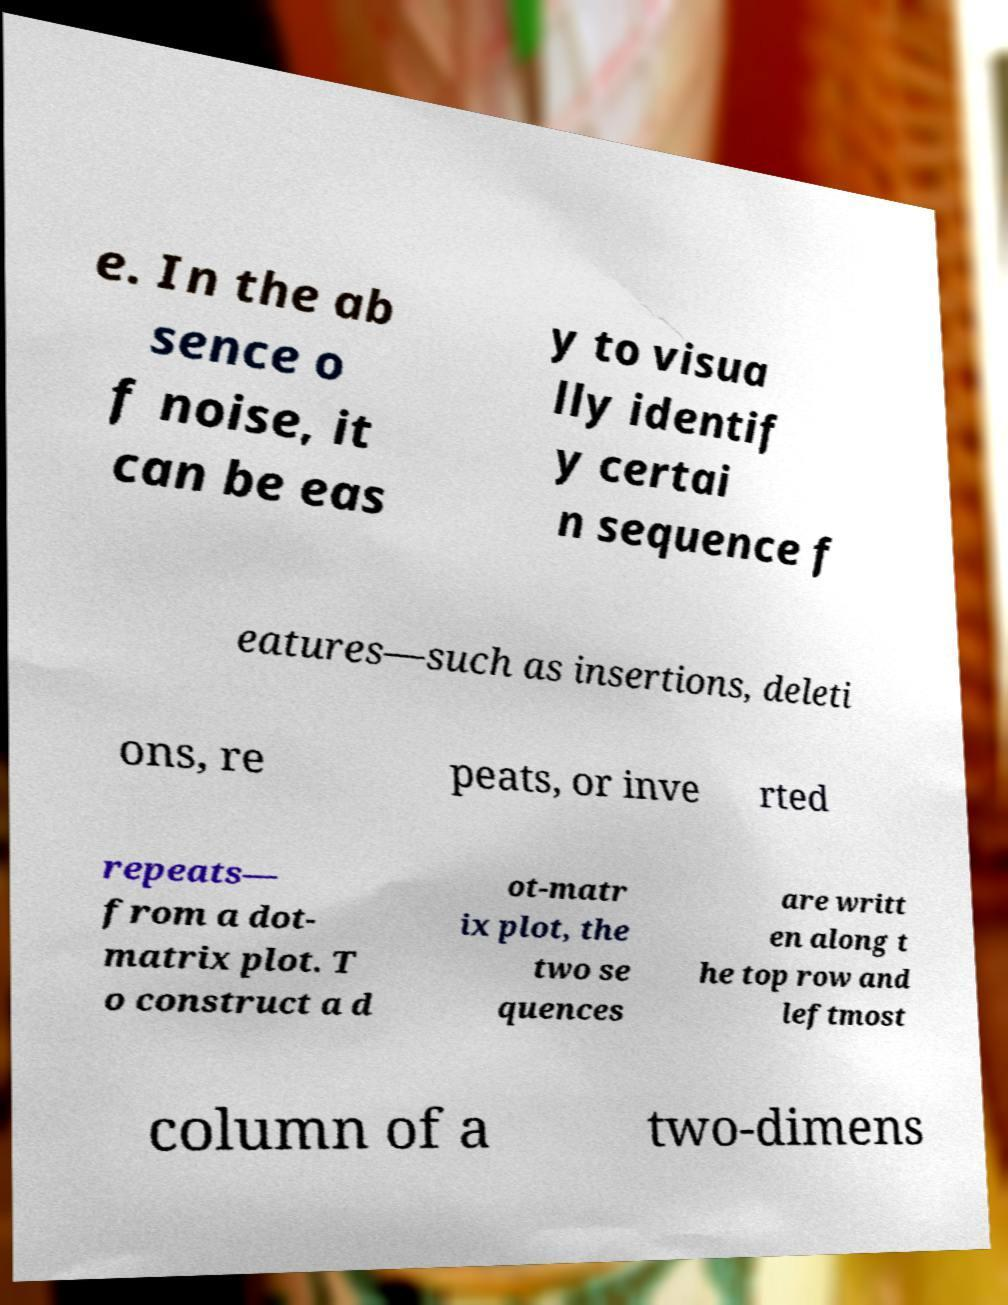Can you read and provide the text displayed in the image?This photo seems to have some interesting text. Can you extract and type it out for me? e. In the ab sence o f noise, it can be eas y to visua lly identif y certai n sequence f eatures—such as insertions, deleti ons, re peats, or inve rted repeats— from a dot- matrix plot. T o construct a d ot-matr ix plot, the two se quences are writt en along t he top row and leftmost column of a two-dimens 